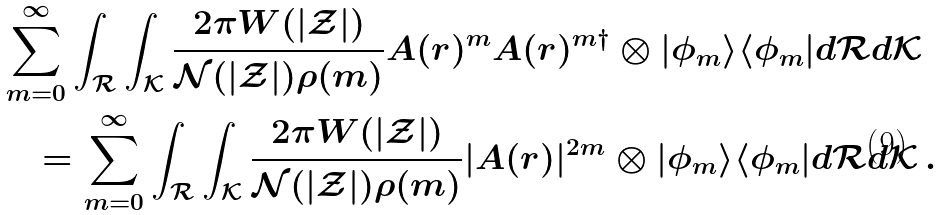<formula> <loc_0><loc_0><loc_500><loc_500>& \sum _ { m = 0 } ^ { \infty } \int _ { \mathcal { R } } \int _ { \mathcal { K } } \frac { 2 \pi W ( | \mathcal { Z } | ) } { \mathcal { N } ( | \mathcal { Z } | ) \rho ( m ) } A ( r ) ^ { m } A ( r ) ^ { m \dagger } \otimes | \phi _ { m } \rangle \langle \phi _ { m } | d \mathcal { R } d \mathcal { K } \\ & \quad = \sum _ { m = 0 } ^ { \infty } \int _ { \mathcal { R } } \int _ { \mathcal { K } } \frac { 2 \pi W ( | \mathcal { Z } | ) } { \mathcal { N } ( | \mathcal { Z } | ) \rho ( m ) } | A ( r ) | ^ { 2 m } \otimes | \phi _ { m } \rangle \langle \phi _ { m } | d \mathcal { R } d \mathcal { K } \, . \\</formula> 